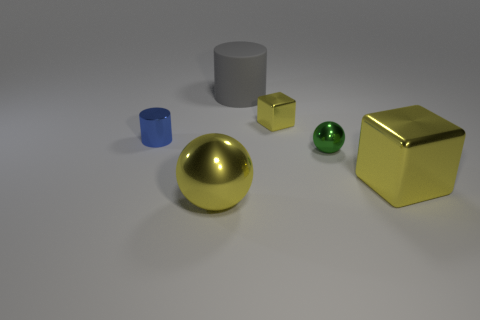Is there any other thing that has the same material as the big gray thing?
Offer a very short reply. No. There is a big object behind the big yellow shiny object that is right of the metallic sphere that is on the left side of the big gray rubber thing; what is its material?
Your answer should be compact. Rubber. Does the block on the left side of the large shiny block have the same material as the big gray cylinder?
Make the answer very short. No. What number of other shiny objects are the same size as the gray object?
Offer a terse response. 2. Is the number of green things behind the large yellow shiny block greater than the number of balls that are on the left side of the yellow metallic ball?
Provide a succinct answer. Yes. Is there a green metallic object of the same shape as the big gray object?
Ensure brevity in your answer.  No. There is a yellow shiny thing that is on the right side of the yellow cube that is to the left of the tiny green metallic object; what size is it?
Give a very brief answer. Large. There is a big yellow thing in front of the large yellow shiny object behind the sphere in front of the big yellow metallic block; what is its shape?
Your answer should be very brief. Sphere. The other ball that is the same material as the small sphere is what size?
Give a very brief answer. Large. Are there more tiny yellow metal blocks than green rubber balls?
Give a very brief answer. Yes. 